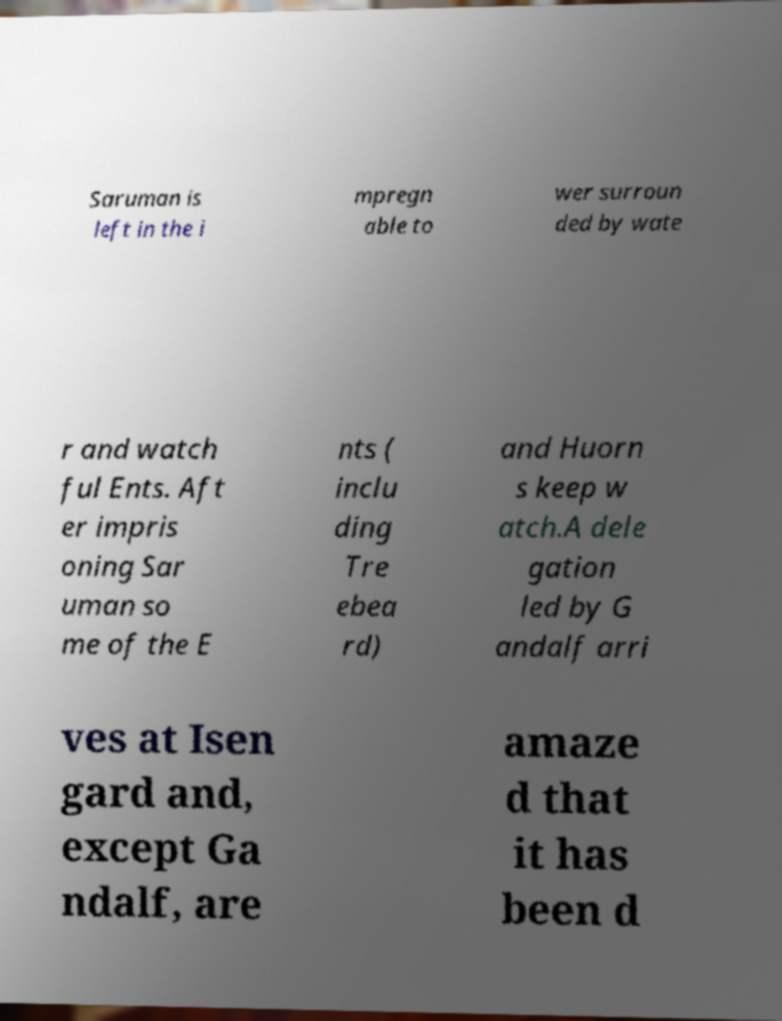Could you assist in decoding the text presented in this image and type it out clearly? Saruman is left in the i mpregn able to wer surroun ded by wate r and watch ful Ents. Aft er impris oning Sar uman so me of the E nts ( inclu ding Tre ebea rd) and Huorn s keep w atch.A dele gation led by G andalf arri ves at Isen gard and, except Ga ndalf, are amaze d that it has been d 